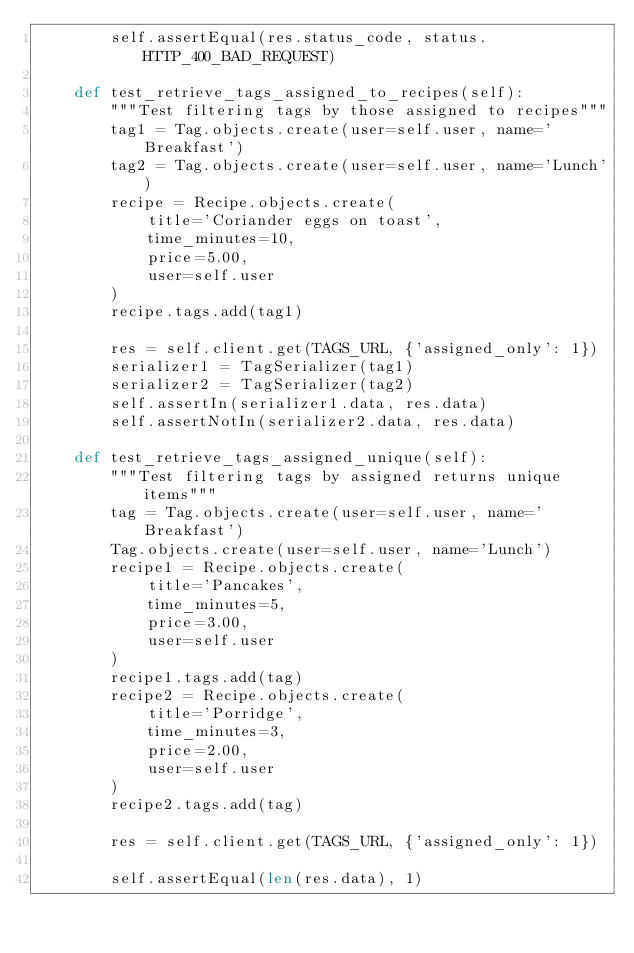<code> <loc_0><loc_0><loc_500><loc_500><_Python_>        self.assertEqual(res.status_code, status.HTTP_400_BAD_REQUEST)

    def test_retrieve_tags_assigned_to_recipes(self):
        """Test filtering tags by those assigned to recipes"""
        tag1 = Tag.objects.create(user=self.user, name='Breakfast')
        tag2 = Tag.objects.create(user=self.user, name='Lunch')
        recipe = Recipe.objects.create(
            title='Coriander eggs on toast',
            time_minutes=10,
            price=5.00,
            user=self.user
        )
        recipe.tags.add(tag1)

        res = self.client.get(TAGS_URL, {'assigned_only': 1})
        serializer1 = TagSerializer(tag1)
        serializer2 = TagSerializer(tag2)
        self.assertIn(serializer1.data, res.data)
        self.assertNotIn(serializer2.data, res.data)

    def test_retrieve_tags_assigned_unique(self):
        """Test filtering tags by assigned returns unique items"""
        tag = Tag.objects.create(user=self.user, name='Breakfast')
        Tag.objects.create(user=self.user, name='Lunch')
        recipe1 = Recipe.objects.create(
            title='Pancakes',
            time_minutes=5,
            price=3.00,
            user=self.user
        )
        recipe1.tags.add(tag)
        recipe2 = Recipe.objects.create(
            title='Porridge',
            time_minutes=3,
            price=2.00,
            user=self.user
        )
        recipe2.tags.add(tag)

        res = self.client.get(TAGS_URL, {'assigned_only': 1})

        self.assertEqual(len(res.data), 1)
</code> 